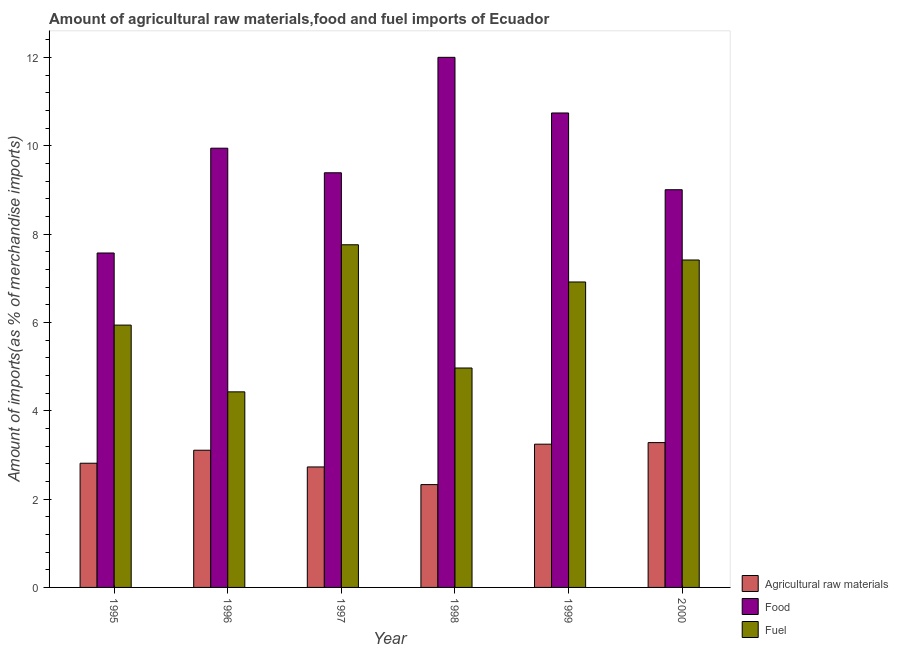How many groups of bars are there?
Offer a terse response. 6. Are the number of bars per tick equal to the number of legend labels?
Keep it short and to the point. Yes. How many bars are there on the 6th tick from the left?
Your answer should be compact. 3. How many bars are there on the 6th tick from the right?
Offer a very short reply. 3. What is the percentage of raw materials imports in 1995?
Provide a short and direct response. 2.81. Across all years, what is the maximum percentage of raw materials imports?
Provide a short and direct response. 3.28. Across all years, what is the minimum percentage of fuel imports?
Offer a terse response. 4.43. In which year was the percentage of fuel imports minimum?
Provide a short and direct response. 1996. What is the total percentage of raw materials imports in the graph?
Provide a succinct answer. 17.5. What is the difference between the percentage of fuel imports in 1999 and that in 2000?
Offer a terse response. -0.5. What is the difference between the percentage of food imports in 1999 and the percentage of fuel imports in 1998?
Your answer should be very brief. -1.26. What is the average percentage of raw materials imports per year?
Keep it short and to the point. 2.92. In the year 1998, what is the difference between the percentage of food imports and percentage of raw materials imports?
Offer a very short reply. 0. In how many years, is the percentage of fuel imports greater than 1.6 %?
Your answer should be compact. 6. What is the ratio of the percentage of fuel imports in 1998 to that in 2000?
Keep it short and to the point. 0.67. Is the percentage of fuel imports in 1995 less than that in 1997?
Your response must be concise. Yes. Is the difference between the percentage of raw materials imports in 1995 and 1999 greater than the difference between the percentage of food imports in 1995 and 1999?
Your answer should be very brief. No. What is the difference between the highest and the second highest percentage of raw materials imports?
Offer a very short reply. 0.04. What is the difference between the highest and the lowest percentage of raw materials imports?
Keep it short and to the point. 0.95. In how many years, is the percentage of raw materials imports greater than the average percentage of raw materials imports taken over all years?
Give a very brief answer. 3. Is the sum of the percentage of food imports in 1995 and 1996 greater than the maximum percentage of fuel imports across all years?
Make the answer very short. Yes. What does the 2nd bar from the left in 2000 represents?
Provide a short and direct response. Food. What does the 3rd bar from the right in 1995 represents?
Keep it short and to the point. Agricultural raw materials. What is the difference between two consecutive major ticks on the Y-axis?
Offer a terse response. 2. Are the values on the major ticks of Y-axis written in scientific E-notation?
Your answer should be compact. No. Does the graph contain any zero values?
Provide a short and direct response. No. What is the title of the graph?
Give a very brief answer. Amount of agricultural raw materials,food and fuel imports of Ecuador. Does "Social Protection and Labor" appear as one of the legend labels in the graph?
Your response must be concise. No. What is the label or title of the Y-axis?
Provide a succinct answer. Amount of imports(as % of merchandise imports). What is the Amount of imports(as % of merchandise imports) of Agricultural raw materials in 1995?
Ensure brevity in your answer.  2.81. What is the Amount of imports(as % of merchandise imports) in Food in 1995?
Provide a short and direct response. 7.57. What is the Amount of imports(as % of merchandise imports) in Fuel in 1995?
Give a very brief answer. 5.94. What is the Amount of imports(as % of merchandise imports) in Agricultural raw materials in 1996?
Your answer should be very brief. 3.11. What is the Amount of imports(as % of merchandise imports) in Food in 1996?
Your answer should be very brief. 9.94. What is the Amount of imports(as % of merchandise imports) in Fuel in 1996?
Keep it short and to the point. 4.43. What is the Amount of imports(as % of merchandise imports) in Agricultural raw materials in 1997?
Offer a terse response. 2.73. What is the Amount of imports(as % of merchandise imports) of Food in 1997?
Your response must be concise. 9.39. What is the Amount of imports(as % of merchandise imports) in Fuel in 1997?
Provide a short and direct response. 7.76. What is the Amount of imports(as % of merchandise imports) of Agricultural raw materials in 1998?
Your answer should be compact. 2.33. What is the Amount of imports(as % of merchandise imports) of Food in 1998?
Keep it short and to the point. 12. What is the Amount of imports(as % of merchandise imports) of Fuel in 1998?
Make the answer very short. 4.97. What is the Amount of imports(as % of merchandise imports) in Agricultural raw materials in 1999?
Your answer should be compact. 3.24. What is the Amount of imports(as % of merchandise imports) of Food in 1999?
Provide a short and direct response. 10.74. What is the Amount of imports(as % of merchandise imports) of Fuel in 1999?
Offer a very short reply. 6.92. What is the Amount of imports(as % of merchandise imports) of Agricultural raw materials in 2000?
Your answer should be compact. 3.28. What is the Amount of imports(as % of merchandise imports) in Food in 2000?
Provide a short and direct response. 9. What is the Amount of imports(as % of merchandise imports) in Fuel in 2000?
Provide a short and direct response. 7.41. Across all years, what is the maximum Amount of imports(as % of merchandise imports) in Agricultural raw materials?
Your response must be concise. 3.28. Across all years, what is the maximum Amount of imports(as % of merchandise imports) in Food?
Your answer should be compact. 12. Across all years, what is the maximum Amount of imports(as % of merchandise imports) of Fuel?
Your response must be concise. 7.76. Across all years, what is the minimum Amount of imports(as % of merchandise imports) of Agricultural raw materials?
Offer a terse response. 2.33. Across all years, what is the minimum Amount of imports(as % of merchandise imports) in Food?
Give a very brief answer. 7.57. Across all years, what is the minimum Amount of imports(as % of merchandise imports) of Fuel?
Offer a very short reply. 4.43. What is the total Amount of imports(as % of merchandise imports) in Agricultural raw materials in the graph?
Make the answer very short. 17.5. What is the total Amount of imports(as % of merchandise imports) in Food in the graph?
Offer a terse response. 58.65. What is the total Amount of imports(as % of merchandise imports) of Fuel in the graph?
Your answer should be very brief. 37.42. What is the difference between the Amount of imports(as % of merchandise imports) of Agricultural raw materials in 1995 and that in 1996?
Ensure brevity in your answer.  -0.29. What is the difference between the Amount of imports(as % of merchandise imports) of Food in 1995 and that in 1996?
Keep it short and to the point. -2.37. What is the difference between the Amount of imports(as % of merchandise imports) in Fuel in 1995 and that in 1996?
Give a very brief answer. 1.51. What is the difference between the Amount of imports(as % of merchandise imports) in Agricultural raw materials in 1995 and that in 1997?
Give a very brief answer. 0.08. What is the difference between the Amount of imports(as % of merchandise imports) of Food in 1995 and that in 1997?
Your response must be concise. -1.82. What is the difference between the Amount of imports(as % of merchandise imports) in Fuel in 1995 and that in 1997?
Provide a succinct answer. -1.82. What is the difference between the Amount of imports(as % of merchandise imports) of Agricultural raw materials in 1995 and that in 1998?
Your answer should be compact. 0.48. What is the difference between the Amount of imports(as % of merchandise imports) of Food in 1995 and that in 1998?
Ensure brevity in your answer.  -4.43. What is the difference between the Amount of imports(as % of merchandise imports) of Fuel in 1995 and that in 1998?
Offer a very short reply. 0.97. What is the difference between the Amount of imports(as % of merchandise imports) of Agricultural raw materials in 1995 and that in 1999?
Your response must be concise. -0.43. What is the difference between the Amount of imports(as % of merchandise imports) in Food in 1995 and that in 1999?
Offer a terse response. -3.17. What is the difference between the Amount of imports(as % of merchandise imports) of Fuel in 1995 and that in 1999?
Your response must be concise. -0.98. What is the difference between the Amount of imports(as % of merchandise imports) of Agricultural raw materials in 1995 and that in 2000?
Ensure brevity in your answer.  -0.47. What is the difference between the Amount of imports(as % of merchandise imports) of Food in 1995 and that in 2000?
Keep it short and to the point. -1.43. What is the difference between the Amount of imports(as % of merchandise imports) of Fuel in 1995 and that in 2000?
Ensure brevity in your answer.  -1.47. What is the difference between the Amount of imports(as % of merchandise imports) of Agricultural raw materials in 1996 and that in 1997?
Your answer should be compact. 0.38. What is the difference between the Amount of imports(as % of merchandise imports) of Food in 1996 and that in 1997?
Your answer should be very brief. 0.56. What is the difference between the Amount of imports(as % of merchandise imports) of Fuel in 1996 and that in 1997?
Your answer should be compact. -3.33. What is the difference between the Amount of imports(as % of merchandise imports) of Agricultural raw materials in 1996 and that in 1998?
Give a very brief answer. 0.78. What is the difference between the Amount of imports(as % of merchandise imports) in Food in 1996 and that in 1998?
Make the answer very short. -2.06. What is the difference between the Amount of imports(as % of merchandise imports) in Fuel in 1996 and that in 1998?
Your answer should be very brief. -0.54. What is the difference between the Amount of imports(as % of merchandise imports) of Agricultural raw materials in 1996 and that in 1999?
Provide a succinct answer. -0.14. What is the difference between the Amount of imports(as % of merchandise imports) in Food in 1996 and that in 1999?
Your answer should be very brief. -0.8. What is the difference between the Amount of imports(as % of merchandise imports) of Fuel in 1996 and that in 1999?
Your answer should be compact. -2.49. What is the difference between the Amount of imports(as % of merchandise imports) in Agricultural raw materials in 1996 and that in 2000?
Make the answer very short. -0.17. What is the difference between the Amount of imports(as % of merchandise imports) of Food in 1996 and that in 2000?
Make the answer very short. 0.94. What is the difference between the Amount of imports(as % of merchandise imports) in Fuel in 1996 and that in 2000?
Your answer should be very brief. -2.99. What is the difference between the Amount of imports(as % of merchandise imports) in Agricultural raw materials in 1997 and that in 1998?
Give a very brief answer. 0.4. What is the difference between the Amount of imports(as % of merchandise imports) of Food in 1997 and that in 1998?
Offer a terse response. -2.61. What is the difference between the Amount of imports(as % of merchandise imports) of Fuel in 1997 and that in 1998?
Ensure brevity in your answer.  2.79. What is the difference between the Amount of imports(as % of merchandise imports) of Agricultural raw materials in 1997 and that in 1999?
Give a very brief answer. -0.52. What is the difference between the Amount of imports(as % of merchandise imports) of Food in 1997 and that in 1999?
Provide a succinct answer. -1.35. What is the difference between the Amount of imports(as % of merchandise imports) of Fuel in 1997 and that in 1999?
Provide a short and direct response. 0.84. What is the difference between the Amount of imports(as % of merchandise imports) of Agricultural raw materials in 1997 and that in 2000?
Keep it short and to the point. -0.55. What is the difference between the Amount of imports(as % of merchandise imports) in Food in 1997 and that in 2000?
Give a very brief answer. 0.38. What is the difference between the Amount of imports(as % of merchandise imports) of Fuel in 1997 and that in 2000?
Provide a short and direct response. 0.34. What is the difference between the Amount of imports(as % of merchandise imports) in Agricultural raw materials in 1998 and that in 1999?
Keep it short and to the point. -0.92. What is the difference between the Amount of imports(as % of merchandise imports) in Food in 1998 and that in 1999?
Ensure brevity in your answer.  1.26. What is the difference between the Amount of imports(as % of merchandise imports) of Fuel in 1998 and that in 1999?
Offer a terse response. -1.95. What is the difference between the Amount of imports(as % of merchandise imports) in Agricultural raw materials in 1998 and that in 2000?
Provide a short and direct response. -0.95. What is the difference between the Amount of imports(as % of merchandise imports) in Food in 1998 and that in 2000?
Ensure brevity in your answer.  3. What is the difference between the Amount of imports(as % of merchandise imports) of Fuel in 1998 and that in 2000?
Offer a terse response. -2.45. What is the difference between the Amount of imports(as % of merchandise imports) in Agricultural raw materials in 1999 and that in 2000?
Make the answer very short. -0.04. What is the difference between the Amount of imports(as % of merchandise imports) of Food in 1999 and that in 2000?
Provide a succinct answer. 1.74. What is the difference between the Amount of imports(as % of merchandise imports) of Fuel in 1999 and that in 2000?
Ensure brevity in your answer.  -0.5. What is the difference between the Amount of imports(as % of merchandise imports) in Agricultural raw materials in 1995 and the Amount of imports(as % of merchandise imports) in Food in 1996?
Give a very brief answer. -7.13. What is the difference between the Amount of imports(as % of merchandise imports) in Agricultural raw materials in 1995 and the Amount of imports(as % of merchandise imports) in Fuel in 1996?
Provide a short and direct response. -1.62. What is the difference between the Amount of imports(as % of merchandise imports) of Food in 1995 and the Amount of imports(as % of merchandise imports) of Fuel in 1996?
Offer a terse response. 3.14. What is the difference between the Amount of imports(as % of merchandise imports) of Agricultural raw materials in 1995 and the Amount of imports(as % of merchandise imports) of Food in 1997?
Your response must be concise. -6.58. What is the difference between the Amount of imports(as % of merchandise imports) of Agricultural raw materials in 1995 and the Amount of imports(as % of merchandise imports) of Fuel in 1997?
Your answer should be very brief. -4.95. What is the difference between the Amount of imports(as % of merchandise imports) in Food in 1995 and the Amount of imports(as % of merchandise imports) in Fuel in 1997?
Keep it short and to the point. -0.19. What is the difference between the Amount of imports(as % of merchandise imports) of Agricultural raw materials in 1995 and the Amount of imports(as % of merchandise imports) of Food in 1998?
Your answer should be very brief. -9.19. What is the difference between the Amount of imports(as % of merchandise imports) of Agricultural raw materials in 1995 and the Amount of imports(as % of merchandise imports) of Fuel in 1998?
Give a very brief answer. -2.16. What is the difference between the Amount of imports(as % of merchandise imports) in Food in 1995 and the Amount of imports(as % of merchandise imports) in Fuel in 1998?
Provide a short and direct response. 2.6. What is the difference between the Amount of imports(as % of merchandise imports) in Agricultural raw materials in 1995 and the Amount of imports(as % of merchandise imports) in Food in 1999?
Your response must be concise. -7.93. What is the difference between the Amount of imports(as % of merchandise imports) of Agricultural raw materials in 1995 and the Amount of imports(as % of merchandise imports) of Fuel in 1999?
Provide a succinct answer. -4.1. What is the difference between the Amount of imports(as % of merchandise imports) of Food in 1995 and the Amount of imports(as % of merchandise imports) of Fuel in 1999?
Your response must be concise. 0.66. What is the difference between the Amount of imports(as % of merchandise imports) in Agricultural raw materials in 1995 and the Amount of imports(as % of merchandise imports) in Food in 2000?
Provide a succinct answer. -6.19. What is the difference between the Amount of imports(as % of merchandise imports) of Agricultural raw materials in 1995 and the Amount of imports(as % of merchandise imports) of Fuel in 2000?
Offer a very short reply. -4.6. What is the difference between the Amount of imports(as % of merchandise imports) of Food in 1995 and the Amount of imports(as % of merchandise imports) of Fuel in 2000?
Give a very brief answer. 0.16. What is the difference between the Amount of imports(as % of merchandise imports) in Agricultural raw materials in 1996 and the Amount of imports(as % of merchandise imports) in Food in 1997?
Your answer should be compact. -6.28. What is the difference between the Amount of imports(as % of merchandise imports) in Agricultural raw materials in 1996 and the Amount of imports(as % of merchandise imports) in Fuel in 1997?
Make the answer very short. -4.65. What is the difference between the Amount of imports(as % of merchandise imports) of Food in 1996 and the Amount of imports(as % of merchandise imports) of Fuel in 1997?
Give a very brief answer. 2.19. What is the difference between the Amount of imports(as % of merchandise imports) of Agricultural raw materials in 1996 and the Amount of imports(as % of merchandise imports) of Food in 1998?
Offer a very short reply. -8.9. What is the difference between the Amount of imports(as % of merchandise imports) of Agricultural raw materials in 1996 and the Amount of imports(as % of merchandise imports) of Fuel in 1998?
Keep it short and to the point. -1.86. What is the difference between the Amount of imports(as % of merchandise imports) of Food in 1996 and the Amount of imports(as % of merchandise imports) of Fuel in 1998?
Give a very brief answer. 4.98. What is the difference between the Amount of imports(as % of merchandise imports) of Agricultural raw materials in 1996 and the Amount of imports(as % of merchandise imports) of Food in 1999?
Offer a terse response. -7.64. What is the difference between the Amount of imports(as % of merchandise imports) in Agricultural raw materials in 1996 and the Amount of imports(as % of merchandise imports) in Fuel in 1999?
Keep it short and to the point. -3.81. What is the difference between the Amount of imports(as % of merchandise imports) of Food in 1996 and the Amount of imports(as % of merchandise imports) of Fuel in 1999?
Offer a very short reply. 3.03. What is the difference between the Amount of imports(as % of merchandise imports) of Agricultural raw materials in 1996 and the Amount of imports(as % of merchandise imports) of Food in 2000?
Your response must be concise. -5.9. What is the difference between the Amount of imports(as % of merchandise imports) in Agricultural raw materials in 1996 and the Amount of imports(as % of merchandise imports) in Fuel in 2000?
Offer a terse response. -4.31. What is the difference between the Amount of imports(as % of merchandise imports) in Food in 1996 and the Amount of imports(as % of merchandise imports) in Fuel in 2000?
Provide a succinct answer. 2.53. What is the difference between the Amount of imports(as % of merchandise imports) of Agricultural raw materials in 1997 and the Amount of imports(as % of merchandise imports) of Food in 1998?
Provide a short and direct response. -9.27. What is the difference between the Amount of imports(as % of merchandise imports) of Agricultural raw materials in 1997 and the Amount of imports(as % of merchandise imports) of Fuel in 1998?
Give a very brief answer. -2.24. What is the difference between the Amount of imports(as % of merchandise imports) of Food in 1997 and the Amount of imports(as % of merchandise imports) of Fuel in 1998?
Offer a terse response. 4.42. What is the difference between the Amount of imports(as % of merchandise imports) in Agricultural raw materials in 1997 and the Amount of imports(as % of merchandise imports) in Food in 1999?
Provide a succinct answer. -8.01. What is the difference between the Amount of imports(as % of merchandise imports) of Agricultural raw materials in 1997 and the Amount of imports(as % of merchandise imports) of Fuel in 1999?
Your answer should be very brief. -4.19. What is the difference between the Amount of imports(as % of merchandise imports) of Food in 1997 and the Amount of imports(as % of merchandise imports) of Fuel in 1999?
Provide a short and direct response. 2.47. What is the difference between the Amount of imports(as % of merchandise imports) of Agricultural raw materials in 1997 and the Amount of imports(as % of merchandise imports) of Food in 2000?
Make the answer very short. -6.28. What is the difference between the Amount of imports(as % of merchandise imports) in Agricultural raw materials in 1997 and the Amount of imports(as % of merchandise imports) in Fuel in 2000?
Keep it short and to the point. -4.69. What is the difference between the Amount of imports(as % of merchandise imports) of Food in 1997 and the Amount of imports(as % of merchandise imports) of Fuel in 2000?
Make the answer very short. 1.97. What is the difference between the Amount of imports(as % of merchandise imports) in Agricultural raw materials in 1998 and the Amount of imports(as % of merchandise imports) in Food in 1999?
Provide a succinct answer. -8.41. What is the difference between the Amount of imports(as % of merchandise imports) of Agricultural raw materials in 1998 and the Amount of imports(as % of merchandise imports) of Fuel in 1999?
Offer a very short reply. -4.59. What is the difference between the Amount of imports(as % of merchandise imports) of Food in 1998 and the Amount of imports(as % of merchandise imports) of Fuel in 1999?
Provide a short and direct response. 5.09. What is the difference between the Amount of imports(as % of merchandise imports) of Agricultural raw materials in 1998 and the Amount of imports(as % of merchandise imports) of Food in 2000?
Your response must be concise. -6.68. What is the difference between the Amount of imports(as % of merchandise imports) of Agricultural raw materials in 1998 and the Amount of imports(as % of merchandise imports) of Fuel in 2000?
Keep it short and to the point. -5.09. What is the difference between the Amount of imports(as % of merchandise imports) in Food in 1998 and the Amount of imports(as % of merchandise imports) in Fuel in 2000?
Offer a very short reply. 4.59. What is the difference between the Amount of imports(as % of merchandise imports) of Agricultural raw materials in 1999 and the Amount of imports(as % of merchandise imports) of Food in 2000?
Provide a short and direct response. -5.76. What is the difference between the Amount of imports(as % of merchandise imports) of Agricultural raw materials in 1999 and the Amount of imports(as % of merchandise imports) of Fuel in 2000?
Your answer should be very brief. -4.17. What is the difference between the Amount of imports(as % of merchandise imports) in Food in 1999 and the Amount of imports(as % of merchandise imports) in Fuel in 2000?
Provide a short and direct response. 3.33. What is the average Amount of imports(as % of merchandise imports) of Agricultural raw materials per year?
Provide a short and direct response. 2.92. What is the average Amount of imports(as % of merchandise imports) in Food per year?
Ensure brevity in your answer.  9.78. What is the average Amount of imports(as % of merchandise imports) of Fuel per year?
Make the answer very short. 6.24. In the year 1995, what is the difference between the Amount of imports(as % of merchandise imports) in Agricultural raw materials and Amount of imports(as % of merchandise imports) in Food?
Your response must be concise. -4.76. In the year 1995, what is the difference between the Amount of imports(as % of merchandise imports) in Agricultural raw materials and Amount of imports(as % of merchandise imports) in Fuel?
Provide a succinct answer. -3.13. In the year 1995, what is the difference between the Amount of imports(as % of merchandise imports) of Food and Amount of imports(as % of merchandise imports) of Fuel?
Make the answer very short. 1.63. In the year 1996, what is the difference between the Amount of imports(as % of merchandise imports) of Agricultural raw materials and Amount of imports(as % of merchandise imports) of Food?
Give a very brief answer. -6.84. In the year 1996, what is the difference between the Amount of imports(as % of merchandise imports) in Agricultural raw materials and Amount of imports(as % of merchandise imports) in Fuel?
Your answer should be very brief. -1.32. In the year 1996, what is the difference between the Amount of imports(as % of merchandise imports) of Food and Amount of imports(as % of merchandise imports) of Fuel?
Your answer should be compact. 5.52. In the year 1997, what is the difference between the Amount of imports(as % of merchandise imports) of Agricultural raw materials and Amount of imports(as % of merchandise imports) of Food?
Provide a succinct answer. -6.66. In the year 1997, what is the difference between the Amount of imports(as % of merchandise imports) in Agricultural raw materials and Amount of imports(as % of merchandise imports) in Fuel?
Your answer should be compact. -5.03. In the year 1997, what is the difference between the Amount of imports(as % of merchandise imports) in Food and Amount of imports(as % of merchandise imports) in Fuel?
Your response must be concise. 1.63. In the year 1998, what is the difference between the Amount of imports(as % of merchandise imports) of Agricultural raw materials and Amount of imports(as % of merchandise imports) of Food?
Your response must be concise. -9.67. In the year 1998, what is the difference between the Amount of imports(as % of merchandise imports) of Agricultural raw materials and Amount of imports(as % of merchandise imports) of Fuel?
Offer a very short reply. -2.64. In the year 1998, what is the difference between the Amount of imports(as % of merchandise imports) of Food and Amount of imports(as % of merchandise imports) of Fuel?
Keep it short and to the point. 7.03. In the year 1999, what is the difference between the Amount of imports(as % of merchandise imports) in Agricultural raw materials and Amount of imports(as % of merchandise imports) in Food?
Your answer should be very brief. -7.5. In the year 1999, what is the difference between the Amount of imports(as % of merchandise imports) in Agricultural raw materials and Amount of imports(as % of merchandise imports) in Fuel?
Your answer should be very brief. -3.67. In the year 1999, what is the difference between the Amount of imports(as % of merchandise imports) in Food and Amount of imports(as % of merchandise imports) in Fuel?
Offer a terse response. 3.83. In the year 2000, what is the difference between the Amount of imports(as % of merchandise imports) in Agricultural raw materials and Amount of imports(as % of merchandise imports) in Food?
Provide a short and direct response. -5.73. In the year 2000, what is the difference between the Amount of imports(as % of merchandise imports) in Agricultural raw materials and Amount of imports(as % of merchandise imports) in Fuel?
Offer a very short reply. -4.13. In the year 2000, what is the difference between the Amount of imports(as % of merchandise imports) in Food and Amount of imports(as % of merchandise imports) in Fuel?
Your answer should be compact. 1.59. What is the ratio of the Amount of imports(as % of merchandise imports) of Agricultural raw materials in 1995 to that in 1996?
Make the answer very short. 0.91. What is the ratio of the Amount of imports(as % of merchandise imports) of Food in 1995 to that in 1996?
Ensure brevity in your answer.  0.76. What is the ratio of the Amount of imports(as % of merchandise imports) in Fuel in 1995 to that in 1996?
Offer a terse response. 1.34. What is the ratio of the Amount of imports(as % of merchandise imports) of Agricultural raw materials in 1995 to that in 1997?
Give a very brief answer. 1.03. What is the ratio of the Amount of imports(as % of merchandise imports) of Food in 1995 to that in 1997?
Your answer should be compact. 0.81. What is the ratio of the Amount of imports(as % of merchandise imports) of Fuel in 1995 to that in 1997?
Your response must be concise. 0.77. What is the ratio of the Amount of imports(as % of merchandise imports) of Agricultural raw materials in 1995 to that in 1998?
Offer a terse response. 1.21. What is the ratio of the Amount of imports(as % of merchandise imports) in Food in 1995 to that in 1998?
Provide a short and direct response. 0.63. What is the ratio of the Amount of imports(as % of merchandise imports) in Fuel in 1995 to that in 1998?
Provide a short and direct response. 1.2. What is the ratio of the Amount of imports(as % of merchandise imports) of Agricultural raw materials in 1995 to that in 1999?
Offer a very short reply. 0.87. What is the ratio of the Amount of imports(as % of merchandise imports) of Food in 1995 to that in 1999?
Keep it short and to the point. 0.7. What is the ratio of the Amount of imports(as % of merchandise imports) in Fuel in 1995 to that in 1999?
Provide a short and direct response. 0.86. What is the ratio of the Amount of imports(as % of merchandise imports) of Agricultural raw materials in 1995 to that in 2000?
Provide a short and direct response. 0.86. What is the ratio of the Amount of imports(as % of merchandise imports) of Food in 1995 to that in 2000?
Make the answer very short. 0.84. What is the ratio of the Amount of imports(as % of merchandise imports) of Fuel in 1995 to that in 2000?
Your answer should be compact. 0.8. What is the ratio of the Amount of imports(as % of merchandise imports) of Agricultural raw materials in 1996 to that in 1997?
Provide a succinct answer. 1.14. What is the ratio of the Amount of imports(as % of merchandise imports) in Food in 1996 to that in 1997?
Your answer should be compact. 1.06. What is the ratio of the Amount of imports(as % of merchandise imports) of Fuel in 1996 to that in 1997?
Your response must be concise. 0.57. What is the ratio of the Amount of imports(as % of merchandise imports) of Agricultural raw materials in 1996 to that in 1998?
Give a very brief answer. 1.33. What is the ratio of the Amount of imports(as % of merchandise imports) of Food in 1996 to that in 1998?
Offer a very short reply. 0.83. What is the ratio of the Amount of imports(as % of merchandise imports) of Fuel in 1996 to that in 1998?
Provide a short and direct response. 0.89. What is the ratio of the Amount of imports(as % of merchandise imports) in Agricultural raw materials in 1996 to that in 1999?
Your answer should be very brief. 0.96. What is the ratio of the Amount of imports(as % of merchandise imports) of Food in 1996 to that in 1999?
Your answer should be very brief. 0.93. What is the ratio of the Amount of imports(as % of merchandise imports) in Fuel in 1996 to that in 1999?
Offer a terse response. 0.64. What is the ratio of the Amount of imports(as % of merchandise imports) in Agricultural raw materials in 1996 to that in 2000?
Offer a terse response. 0.95. What is the ratio of the Amount of imports(as % of merchandise imports) of Food in 1996 to that in 2000?
Ensure brevity in your answer.  1.1. What is the ratio of the Amount of imports(as % of merchandise imports) of Fuel in 1996 to that in 2000?
Offer a terse response. 0.6. What is the ratio of the Amount of imports(as % of merchandise imports) in Agricultural raw materials in 1997 to that in 1998?
Your answer should be compact. 1.17. What is the ratio of the Amount of imports(as % of merchandise imports) of Food in 1997 to that in 1998?
Keep it short and to the point. 0.78. What is the ratio of the Amount of imports(as % of merchandise imports) of Fuel in 1997 to that in 1998?
Keep it short and to the point. 1.56. What is the ratio of the Amount of imports(as % of merchandise imports) in Agricultural raw materials in 1997 to that in 1999?
Offer a very short reply. 0.84. What is the ratio of the Amount of imports(as % of merchandise imports) of Food in 1997 to that in 1999?
Give a very brief answer. 0.87. What is the ratio of the Amount of imports(as % of merchandise imports) of Fuel in 1997 to that in 1999?
Keep it short and to the point. 1.12. What is the ratio of the Amount of imports(as % of merchandise imports) of Agricultural raw materials in 1997 to that in 2000?
Make the answer very short. 0.83. What is the ratio of the Amount of imports(as % of merchandise imports) in Food in 1997 to that in 2000?
Give a very brief answer. 1.04. What is the ratio of the Amount of imports(as % of merchandise imports) in Fuel in 1997 to that in 2000?
Make the answer very short. 1.05. What is the ratio of the Amount of imports(as % of merchandise imports) in Agricultural raw materials in 1998 to that in 1999?
Your response must be concise. 0.72. What is the ratio of the Amount of imports(as % of merchandise imports) in Food in 1998 to that in 1999?
Make the answer very short. 1.12. What is the ratio of the Amount of imports(as % of merchandise imports) in Fuel in 1998 to that in 1999?
Provide a succinct answer. 0.72. What is the ratio of the Amount of imports(as % of merchandise imports) in Agricultural raw materials in 1998 to that in 2000?
Make the answer very short. 0.71. What is the ratio of the Amount of imports(as % of merchandise imports) in Food in 1998 to that in 2000?
Offer a very short reply. 1.33. What is the ratio of the Amount of imports(as % of merchandise imports) of Fuel in 1998 to that in 2000?
Offer a very short reply. 0.67. What is the ratio of the Amount of imports(as % of merchandise imports) in Food in 1999 to that in 2000?
Provide a succinct answer. 1.19. What is the ratio of the Amount of imports(as % of merchandise imports) of Fuel in 1999 to that in 2000?
Keep it short and to the point. 0.93. What is the difference between the highest and the second highest Amount of imports(as % of merchandise imports) in Agricultural raw materials?
Provide a short and direct response. 0.04. What is the difference between the highest and the second highest Amount of imports(as % of merchandise imports) of Food?
Provide a succinct answer. 1.26. What is the difference between the highest and the second highest Amount of imports(as % of merchandise imports) of Fuel?
Your response must be concise. 0.34. What is the difference between the highest and the lowest Amount of imports(as % of merchandise imports) of Agricultural raw materials?
Provide a short and direct response. 0.95. What is the difference between the highest and the lowest Amount of imports(as % of merchandise imports) in Food?
Offer a very short reply. 4.43. What is the difference between the highest and the lowest Amount of imports(as % of merchandise imports) in Fuel?
Your answer should be compact. 3.33. 